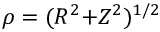<formula> <loc_0><loc_0><loc_500><loc_500>\rho = ( R ^ { 2 } { + } Z ^ { 2 } ) ^ { 1 / 2 }</formula> 